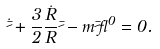Convert formula to latex. <formula><loc_0><loc_0><loc_500><loc_500>\dot { \bar { \psi } } + \frac { 3 } { 2 } \frac { \dot { R } } { R } \bar { \psi } - m \bar { \psi } \gamma ^ { 0 } = 0 .</formula> 